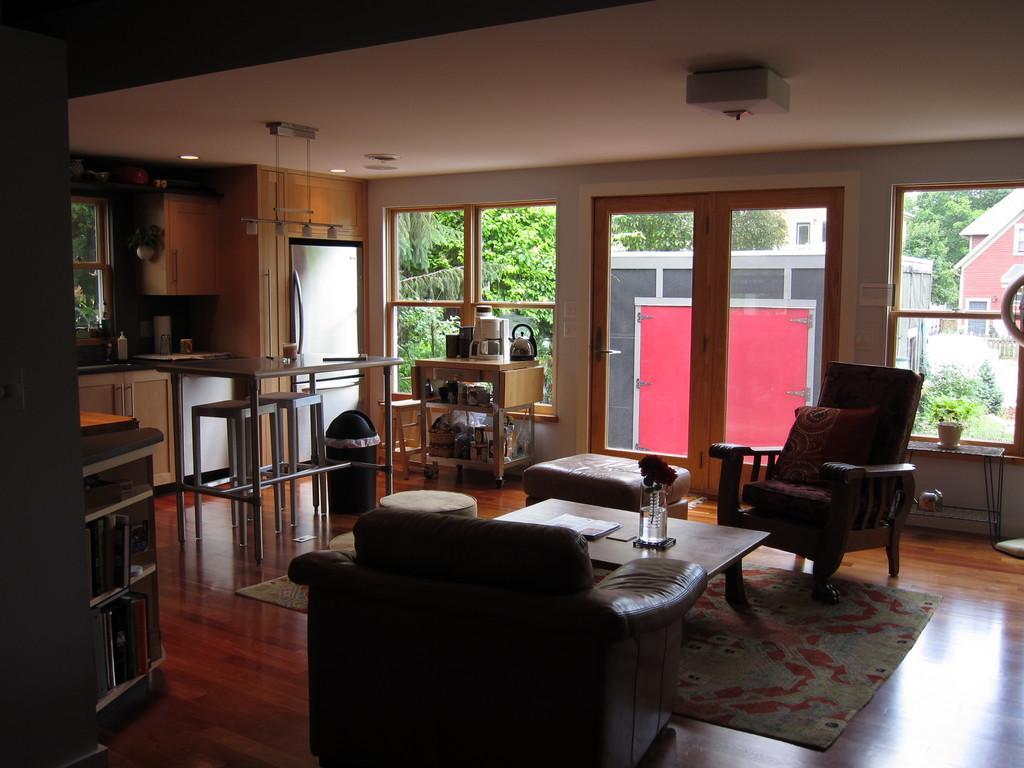Describe this image in one or two sentences. This image is taken into a living room. At the center of the image there is a table, around the table there is a couch, chair and a stool. On the left side of the image there is a kitchen platform with some utensils on it and there is a table stored with the book, beside the platform, there is a refrigerator, beside that there is a table with some stuff on it, behind that there is a glass door. In the background there are trees and buildings. 